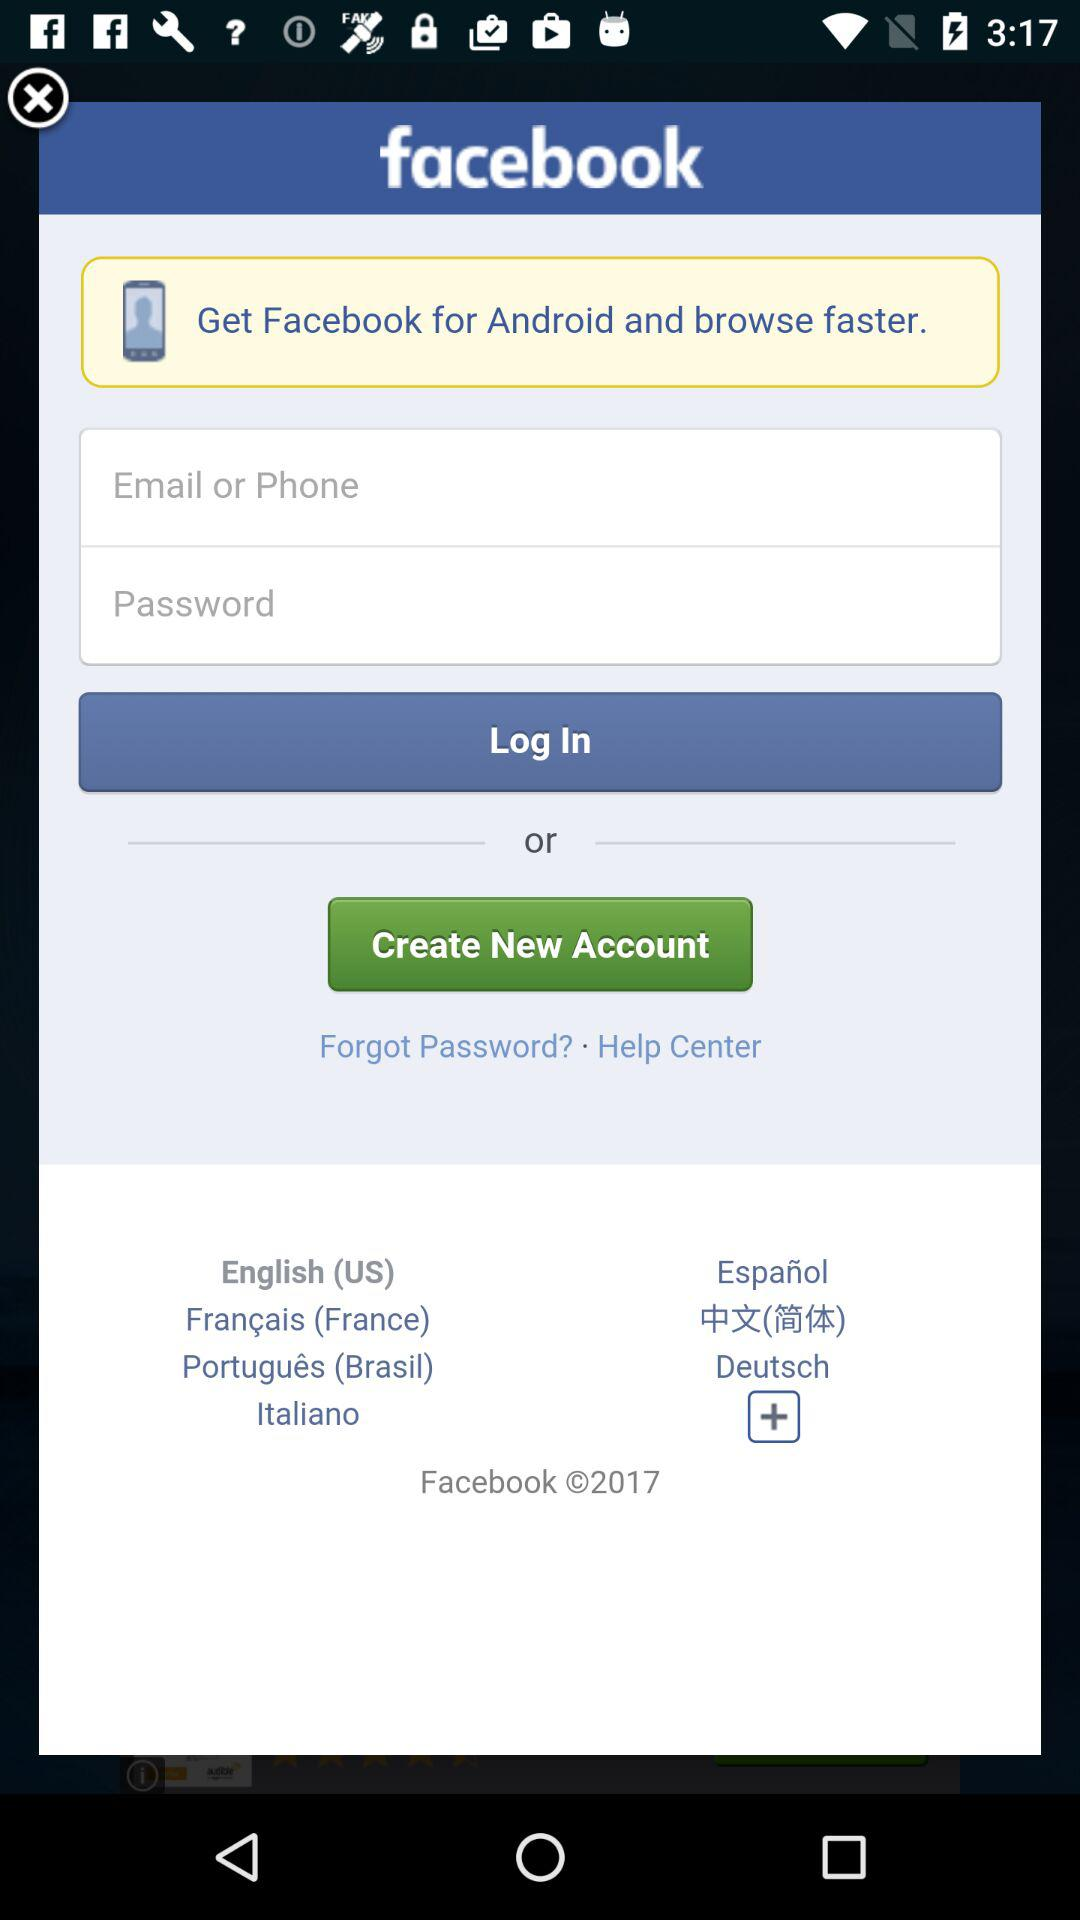What is the name of the application? The application name is "facebook". 